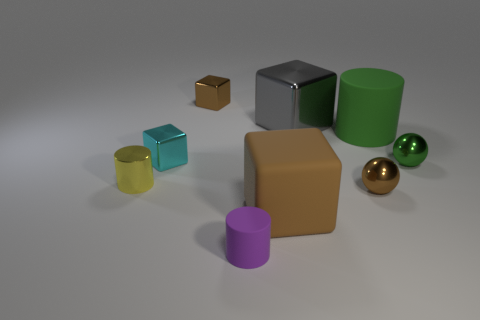Subtract all blue blocks. Subtract all green spheres. How many blocks are left? 4 Add 1 blocks. How many objects exist? 10 Subtract all blocks. How many objects are left? 5 Subtract 0 gray cylinders. How many objects are left? 9 Subtract all big gray cubes. Subtract all green rubber cylinders. How many objects are left? 7 Add 5 blocks. How many blocks are left? 9 Add 8 small shiny cubes. How many small shiny cubes exist? 10 